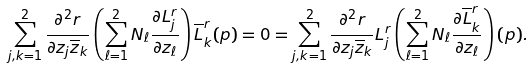<formula> <loc_0><loc_0><loc_500><loc_500>\sum _ { j , k = 1 } ^ { 2 } \frac { \partial ^ { 2 } r } { \partial z _ { j } \overline { z } _ { k } } \left ( \sum _ { \ell = 1 } ^ { 2 } N _ { \ell } \frac { \partial L ^ { r } _ { j } } { \partial z _ { \ell } } \right ) \overline { L } ^ { r } _ { k } ( p ) = 0 = \sum _ { j , k = 1 } ^ { 2 } \frac { \partial ^ { 2 } r } { \partial z _ { j } \overline { z } _ { k } } L _ { j } ^ { r } \left ( \sum _ { \ell = 1 } ^ { 2 } N _ { \ell } \frac { \partial \overline { L } ^ { r } _ { k } } { \partial z _ { \ell } } \right ) ( p ) .</formula> 